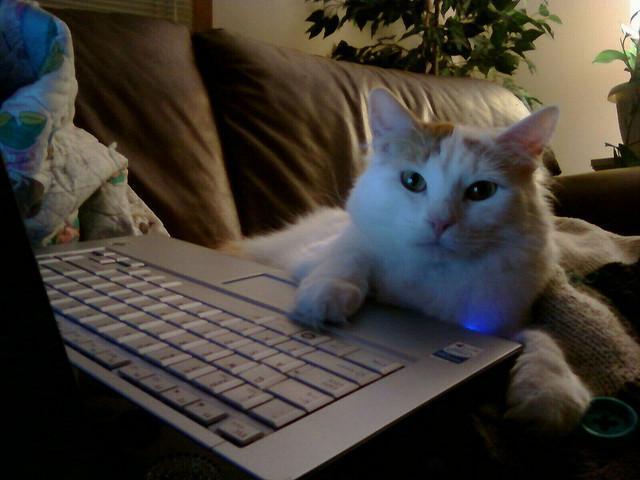How many cats are shown?
Give a very brief answer. 1. How many lights are on the side of the laptop?
Give a very brief answer. 1. How many potted plants are in the picture?
Give a very brief answer. 2. How many couches are there?
Give a very brief answer. 1. 